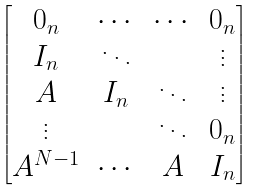Convert formula to latex. <formula><loc_0><loc_0><loc_500><loc_500>\begin{bmatrix} 0 _ { n } & \cdots & \cdots & 0 _ { n } \\ I _ { n } & \ddots & & \vdots \\ A & I _ { n } & \ddots & \vdots \\ \vdots & & \ddots & 0 _ { n } \\ A ^ { N - 1 } & \cdots & A & I _ { n } \end{bmatrix}</formula> 